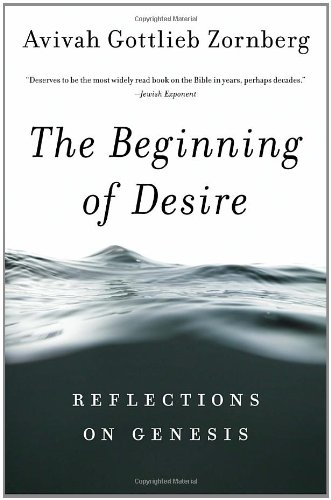Is this book related to Religion & Spirituality? Yes, this book delves into religious and spiritual themes, examining the biblical text of Genesis with a focus on theological and philosophical interpretations. 